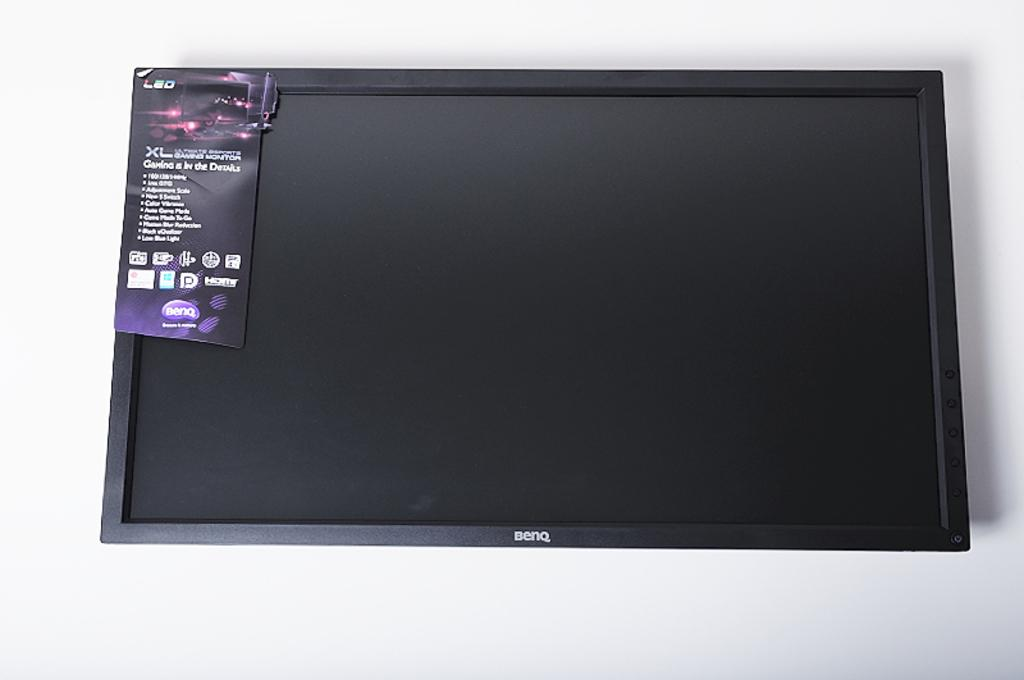<image>
Offer a succinct explanation of the picture presented. A Benq tv has a tag in the top left corner that indicates it is an LED screen. 